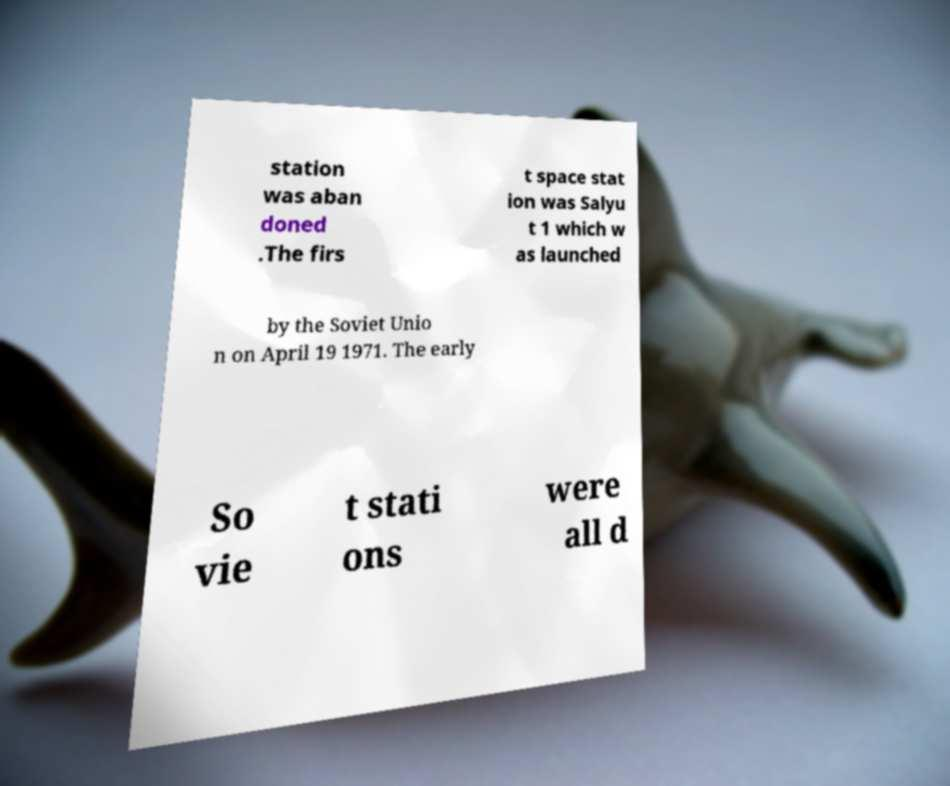For documentation purposes, I need the text within this image transcribed. Could you provide that? station was aban doned .The firs t space stat ion was Salyu t 1 which w as launched by the Soviet Unio n on April 19 1971. The early So vie t stati ons were all d 